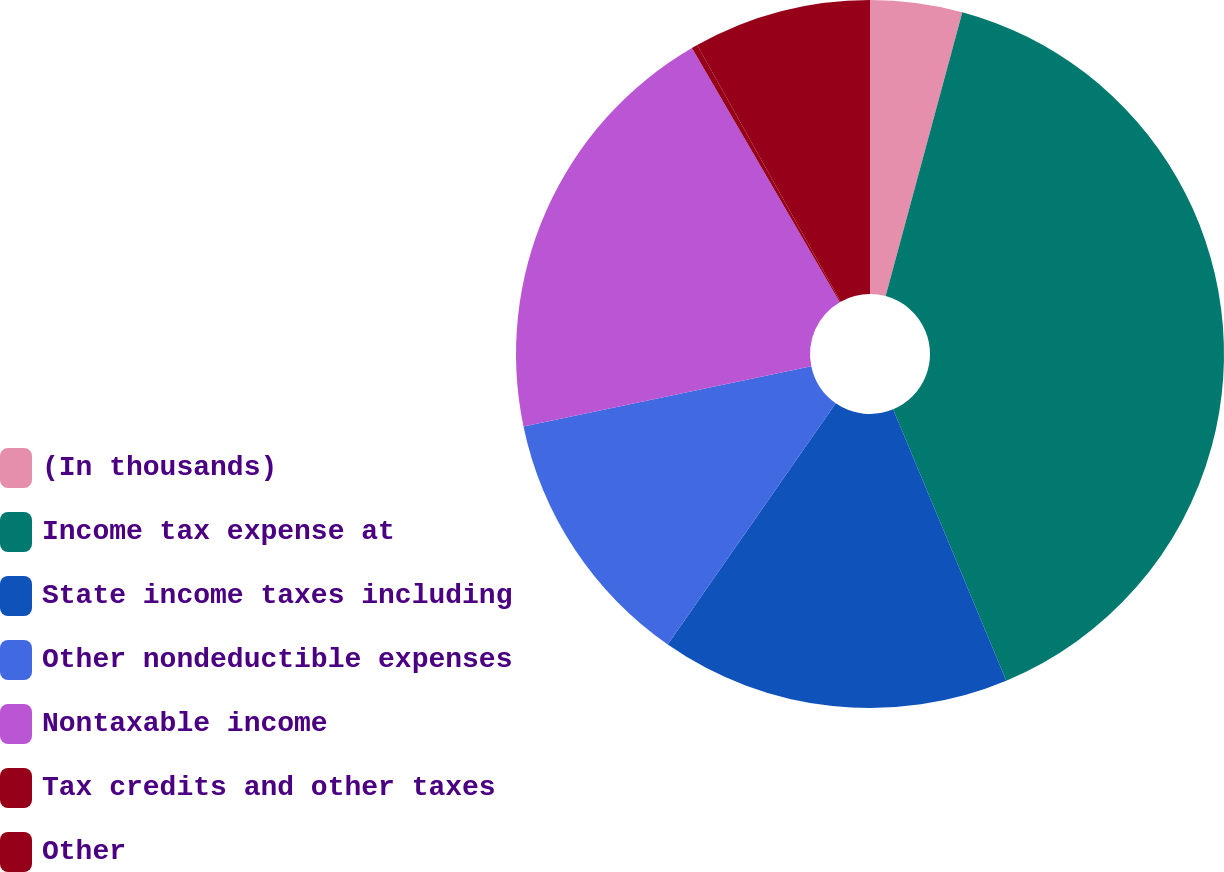Convert chart. <chart><loc_0><loc_0><loc_500><loc_500><pie_chart><fcel>(In thousands)<fcel>Income tax expense at<fcel>State income taxes including<fcel>Other nondeductible expenses<fcel>Nontaxable income<fcel>Tax credits and other taxes<fcel>Other<nl><fcel>4.2%<fcel>39.51%<fcel>15.97%<fcel>12.04%<fcel>19.89%<fcel>0.27%<fcel>8.12%<nl></chart> 